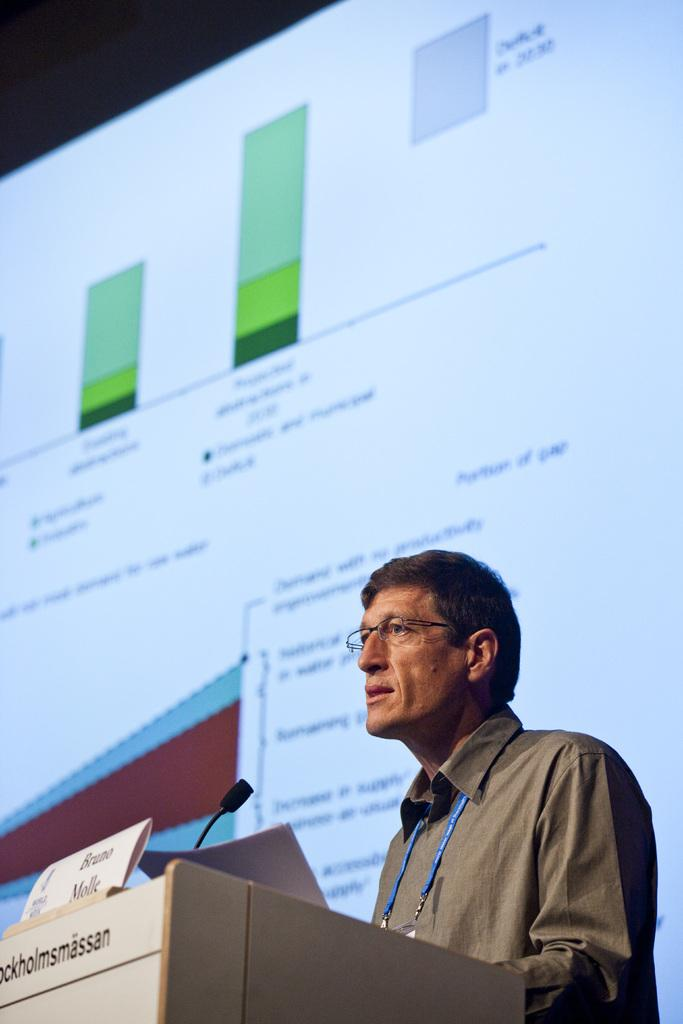Who is the main subject in the image? There is a man in the image. What is the man doing in the image? The man is standing at a podium. What is the man holding in his hands? The man is holding a paper in his hands. What can be seen in the background of the image? There is a display screen in the background of the image. What type of boats can be seen sailing in the background of the image? There are no boats present in the image; it features a man standing at a podium with a paper in his hands and a display screen in the background. 